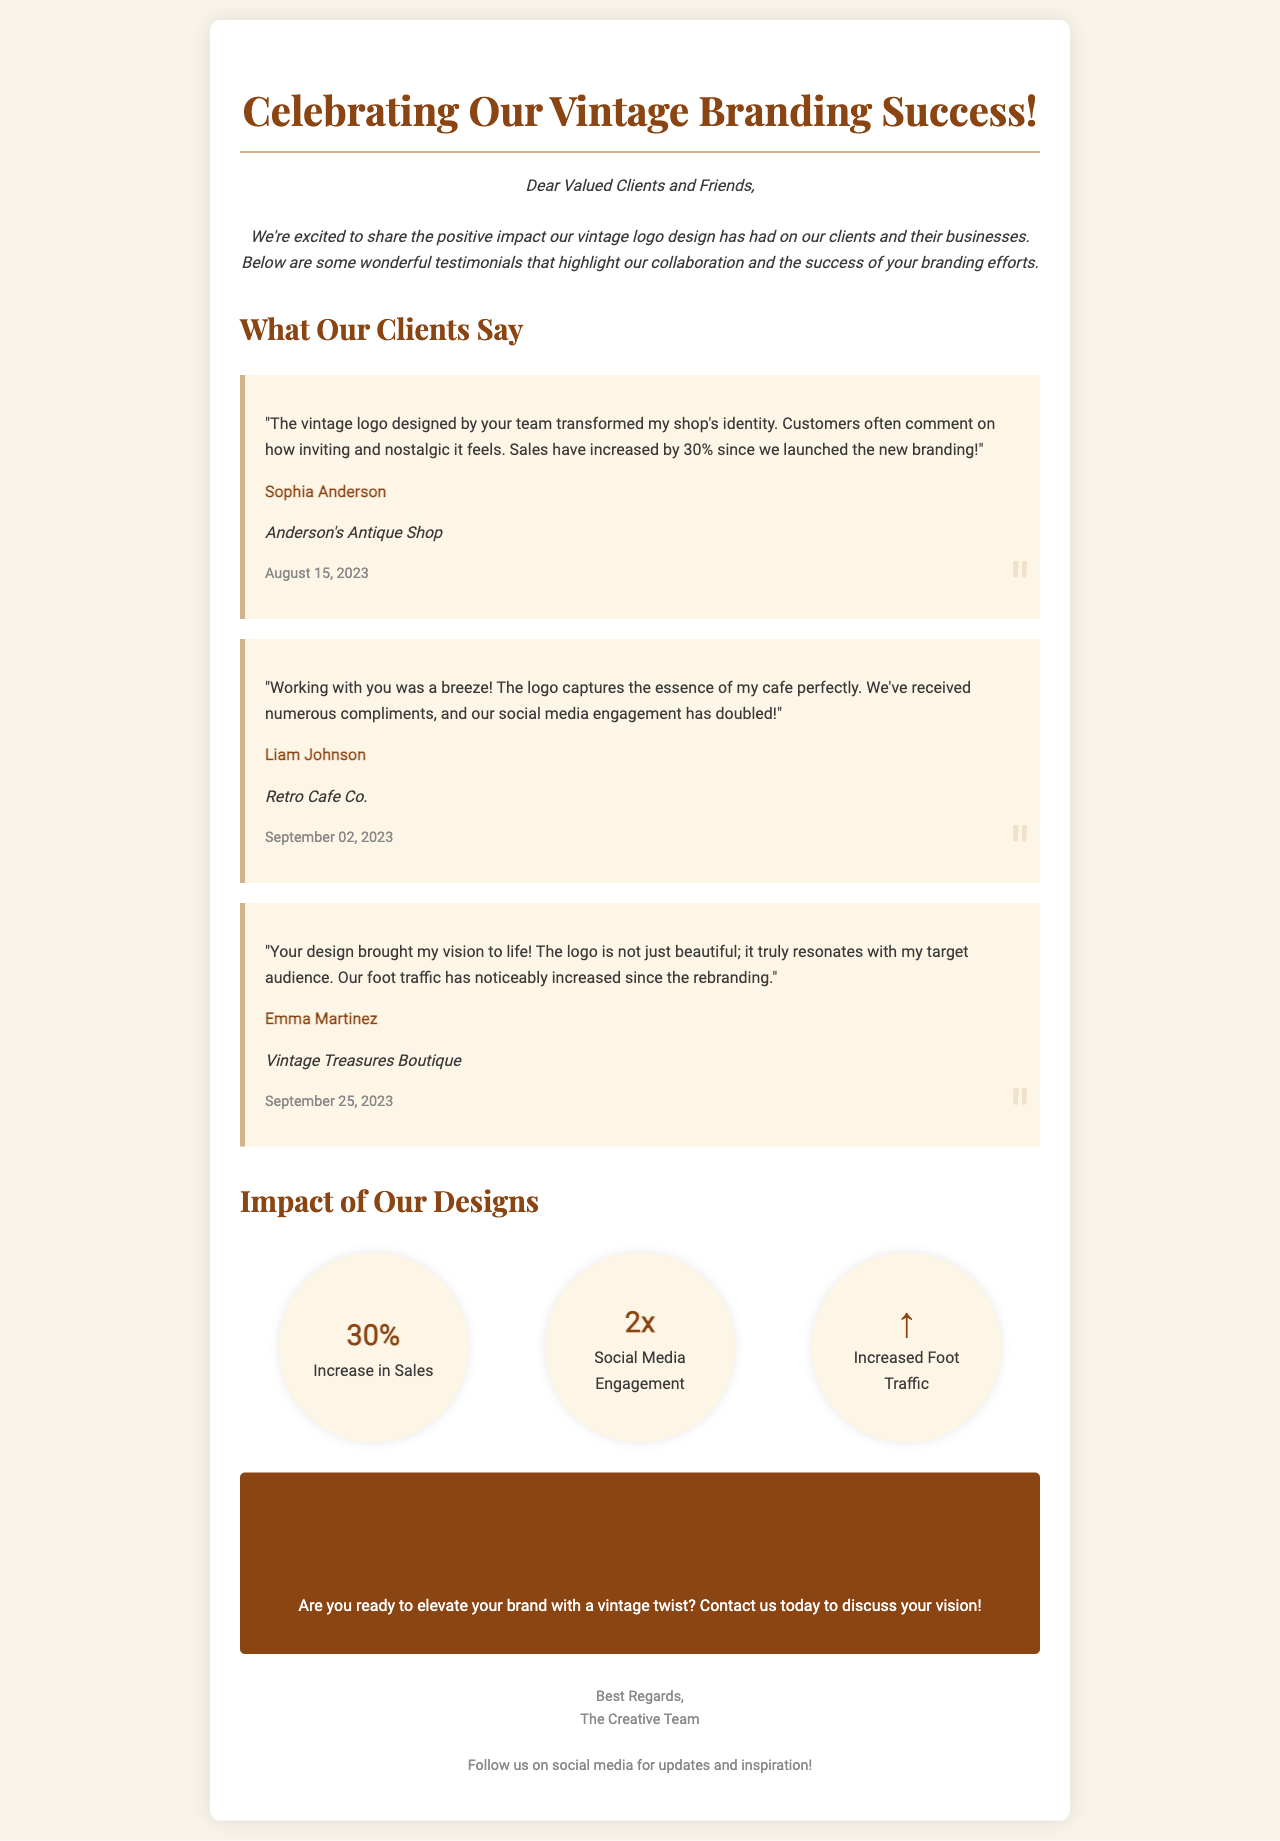What is the title of the document? The title of the document is mentioned in the `<title>` tag of the HTML code.
Answer: Celebrating Our Vintage Branding Success! Who is the client providing feedback from "Anderson's Antique Shop"? The client name is specified in the testimonial section for Anderson's Antique Shop.
Answer: Sophia Anderson What percentage increase in sales is mentioned in the testimonials? The percentage is explicitly stated in the testimonial from Anderson's Antique Shop.
Answer: 30% What is the name of the business mentioned by Liam Johnson? The business name is stated in the testimonial given by Liam Johnson.
Answer: Retro Cafe Co What impact is indicated by the "2x" mentioned in the document? The "2x" refers to a quantifiable increase in a specific area as outlined in the impact section.
Answer: Social Media Engagement Which business experienced increased foot traffic according to the document? The document specifies which business achieved this in the testimonial from Emma Martinez.
Answer: Vintage Treasures Boutique What is the main call to action presented in the document? The call to action is highlighted in the designated section of the document encouraging engagement.
Answer: Ready to Elevate Your Brand? On what date did Sophia Anderson provide her feedback? The specific date of feedback is mentioned in the testimonial for Anderson's Antique Shop.
Answer: August 15, 2023 What color is used for the impact items' background? The background color for the impact items is indicated in the CSS section of the document.
Answer: #fdf5e6 